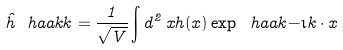<formula> <loc_0><loc_0><loc_500><loc_500>\hat { h } \ h a a k { k } = \frac { 1 } { \sqrt { V } } \int d ^ { 2 } \, x h ( x ) \exp \ h a a k { - \imath k \cdot x }</formula> 